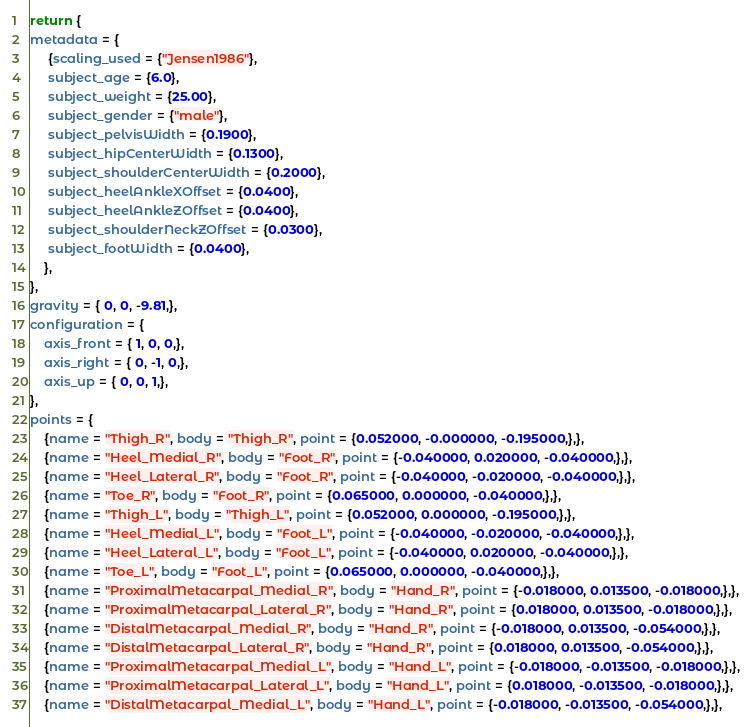<code> <loc_0><loc_0><loc_500><loc_500><_Lua_>return {
metadata = {
	 {scaling_used = {"Jensen1986"},
	 subject_age = {6.0},
	 subject_weight = {25.00},
	 subject_gender = {"male"},
	 subject_pelvisWidth = {0.1900},
	 subject_hipCenterWidth = {0.1300},
	 subject_shoulderCenterWidth = {0.2000},
	 subject_heelAnkleXOffset = {0.0400},
	 subject_heelAnkleZOffset = {0.0400},
	 subject_shoulderNeckZOffset = {0.0300},
	 subject_footWidth = {0.0400},
	},
},
gravity = { 0, 0, -9.81,},
configuration = {
	axis_front = { 1, 0, 0,},
	axis_right = { 0, -1, 0,},
	axis_up = { 0, 0, 1,},
},
points = {
	{name = "Thigh_R", body = "Thigh_R", point = {0.052000, -0.000000, -0.195000,},},
	{name = "Heel_Medial_R", body = "Foot_R", point = {-0.040000, 0.020000, -0.040000,},},
	{name = "Heel_Lateral_R", body = "Foot_R", point = {-0.040000, -0.020000, -0.040000,},},
	{name = "Toe_R", body = "Foot_R", point = {0.065000, 0.000000, -0.040000,},},
	{name = "Thigh_L", body = "Thigh_L", point = {0.052000, 0.000000, -0.195000,},},
	{name = "Heel_Medial_L", body = "Foot_L", point = {-0.040000, -0.020000, -0.040000,},},
	{name = "Heel_Lateral_L", body = "Foot_L", point = {-0.040000, 0.020000, -0.040000,},},
	{name = "Toe_L", body = "Foot_L", point = {0.065000, 0.000000, -0.040000,},},
	{name = "ProximalMetacarpal_Medial_R", body = "Hand_R", point = {-0.018000, 0.013500, -0.018000,},},
	{name = "ProximalMetacarpal_Lateral_R", body = "Hand_R", point = {0.018000, 0.013500, -0.018000,},},
	{name = "DistalMetacarpal_Medial_R", body = "Hand_R", point = {-0.018000, 0.013500, -0.054000,},},
	{name = "DistalMetacarpal_Lateral_R", body = "Hand_R", point = {0.018000, 0.013500, -0.054000,},},
	{name = "ProximalMetacarpal_Medial_L", body = "Hand_L", point = {-0.018000, -0.013500, -0.018000,},},
	{name = "ProximalMetacarpal_Lateral_L", body = "Hand_L", point = {0.018000, -0.013500, -0.018000,},},
	{name = "DistalMetacarpal_Medial_L", body = "Hand_L", point = {-0.018000, -0.013500, -0.054000,},},</code> 